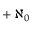<formula> <loc_0><loc_0><loc_500><loc_500>\, + \, \aleph _ { 0 }</formula> 